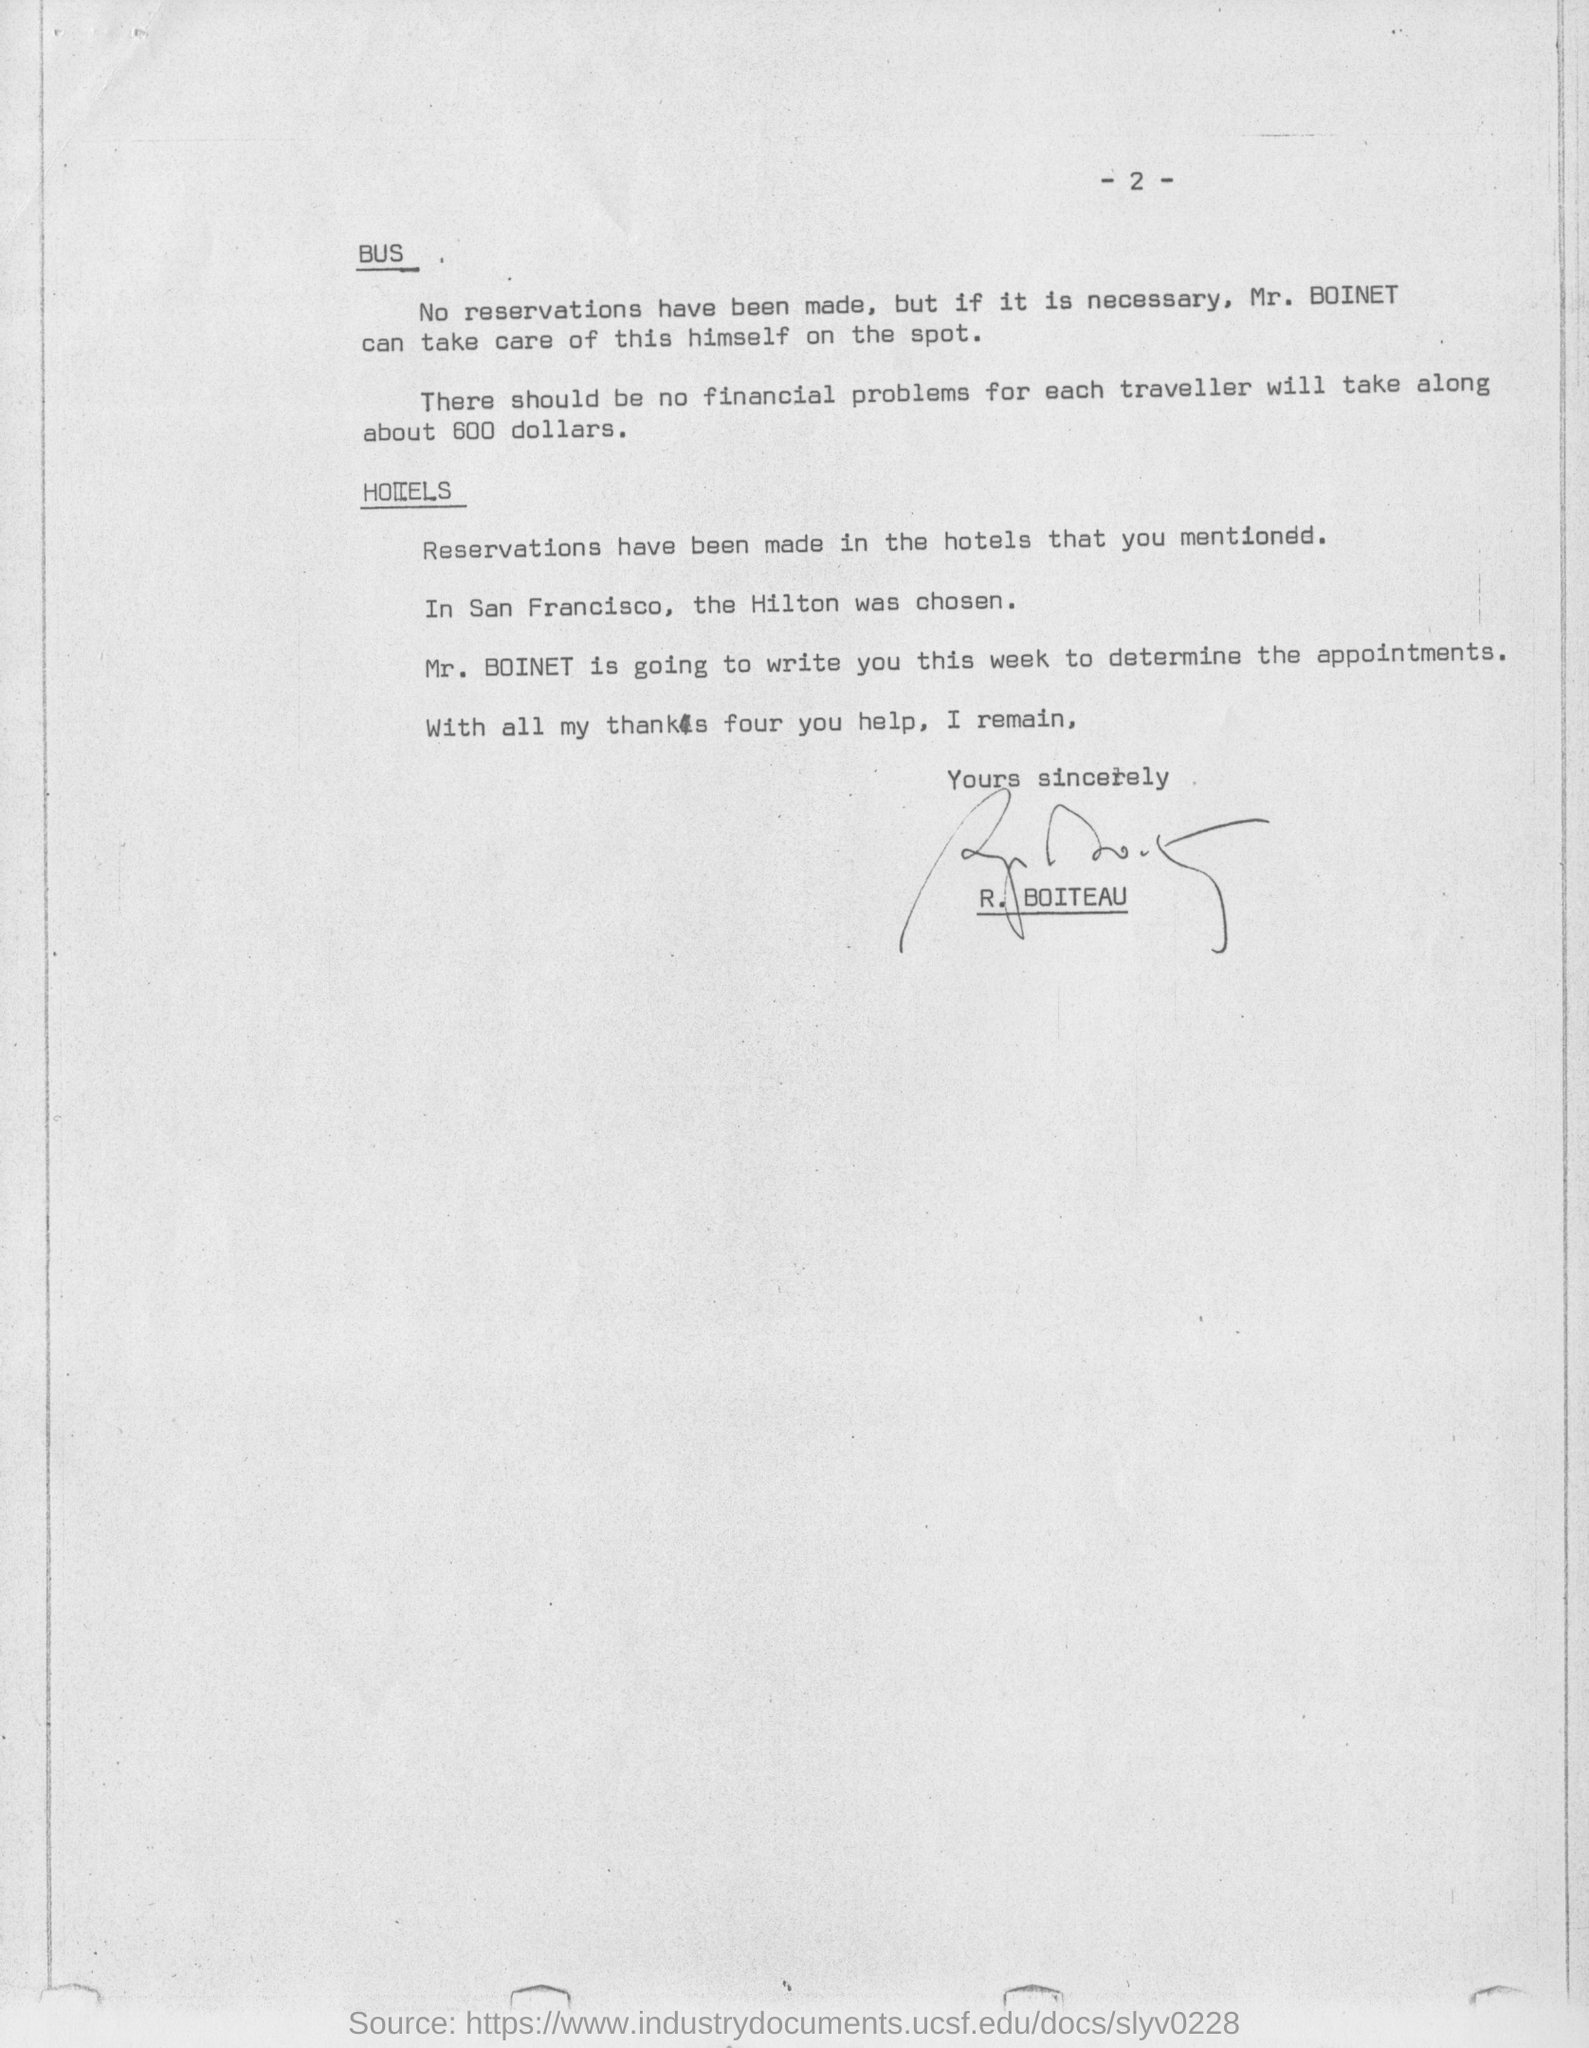Specify some key components in this picture. It is recommended that each traveler bring approximately 600 dollars to cover the cost of expenses during their trip. The document has been signed by R. BOITEAU. The reservation has not been made for Mr. Boinet. 